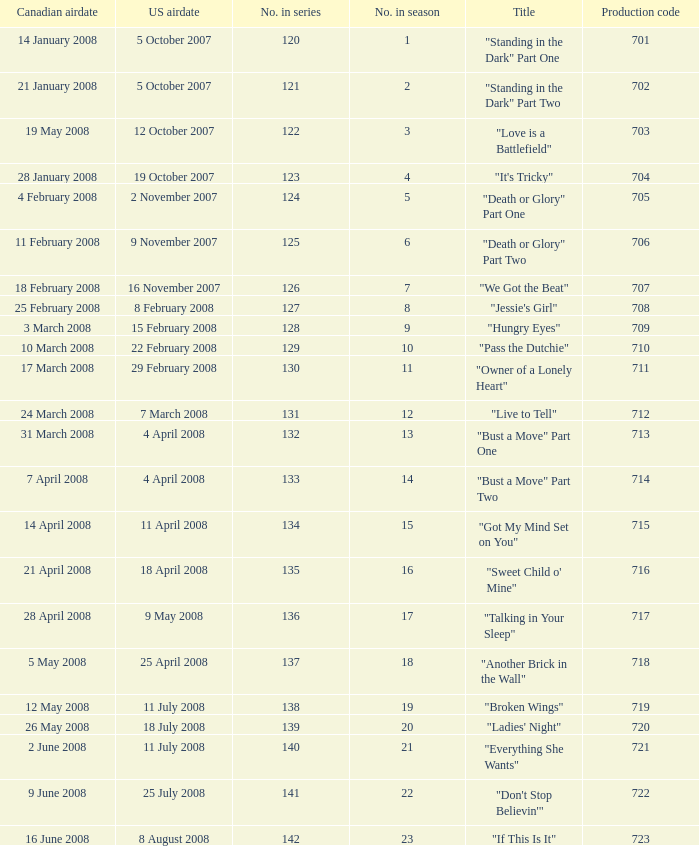For the episode(s) aired in the U.S. on 4 april 2008, what were the names? "Bust a Move" Part One, "Bust a Move" Part Two. 